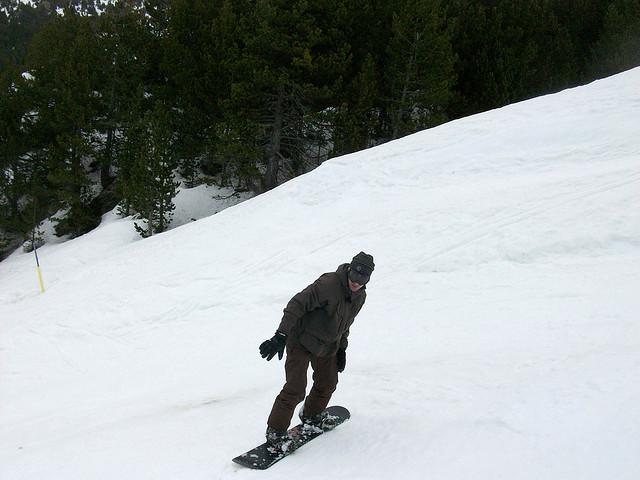What color is the man's cap?
Give a very brief answer. Black. Is the man going east, west, south or northbound?
Write a very short answer. South. Is he traveling uphill or downhill?
Concise answer only. Downhill. 